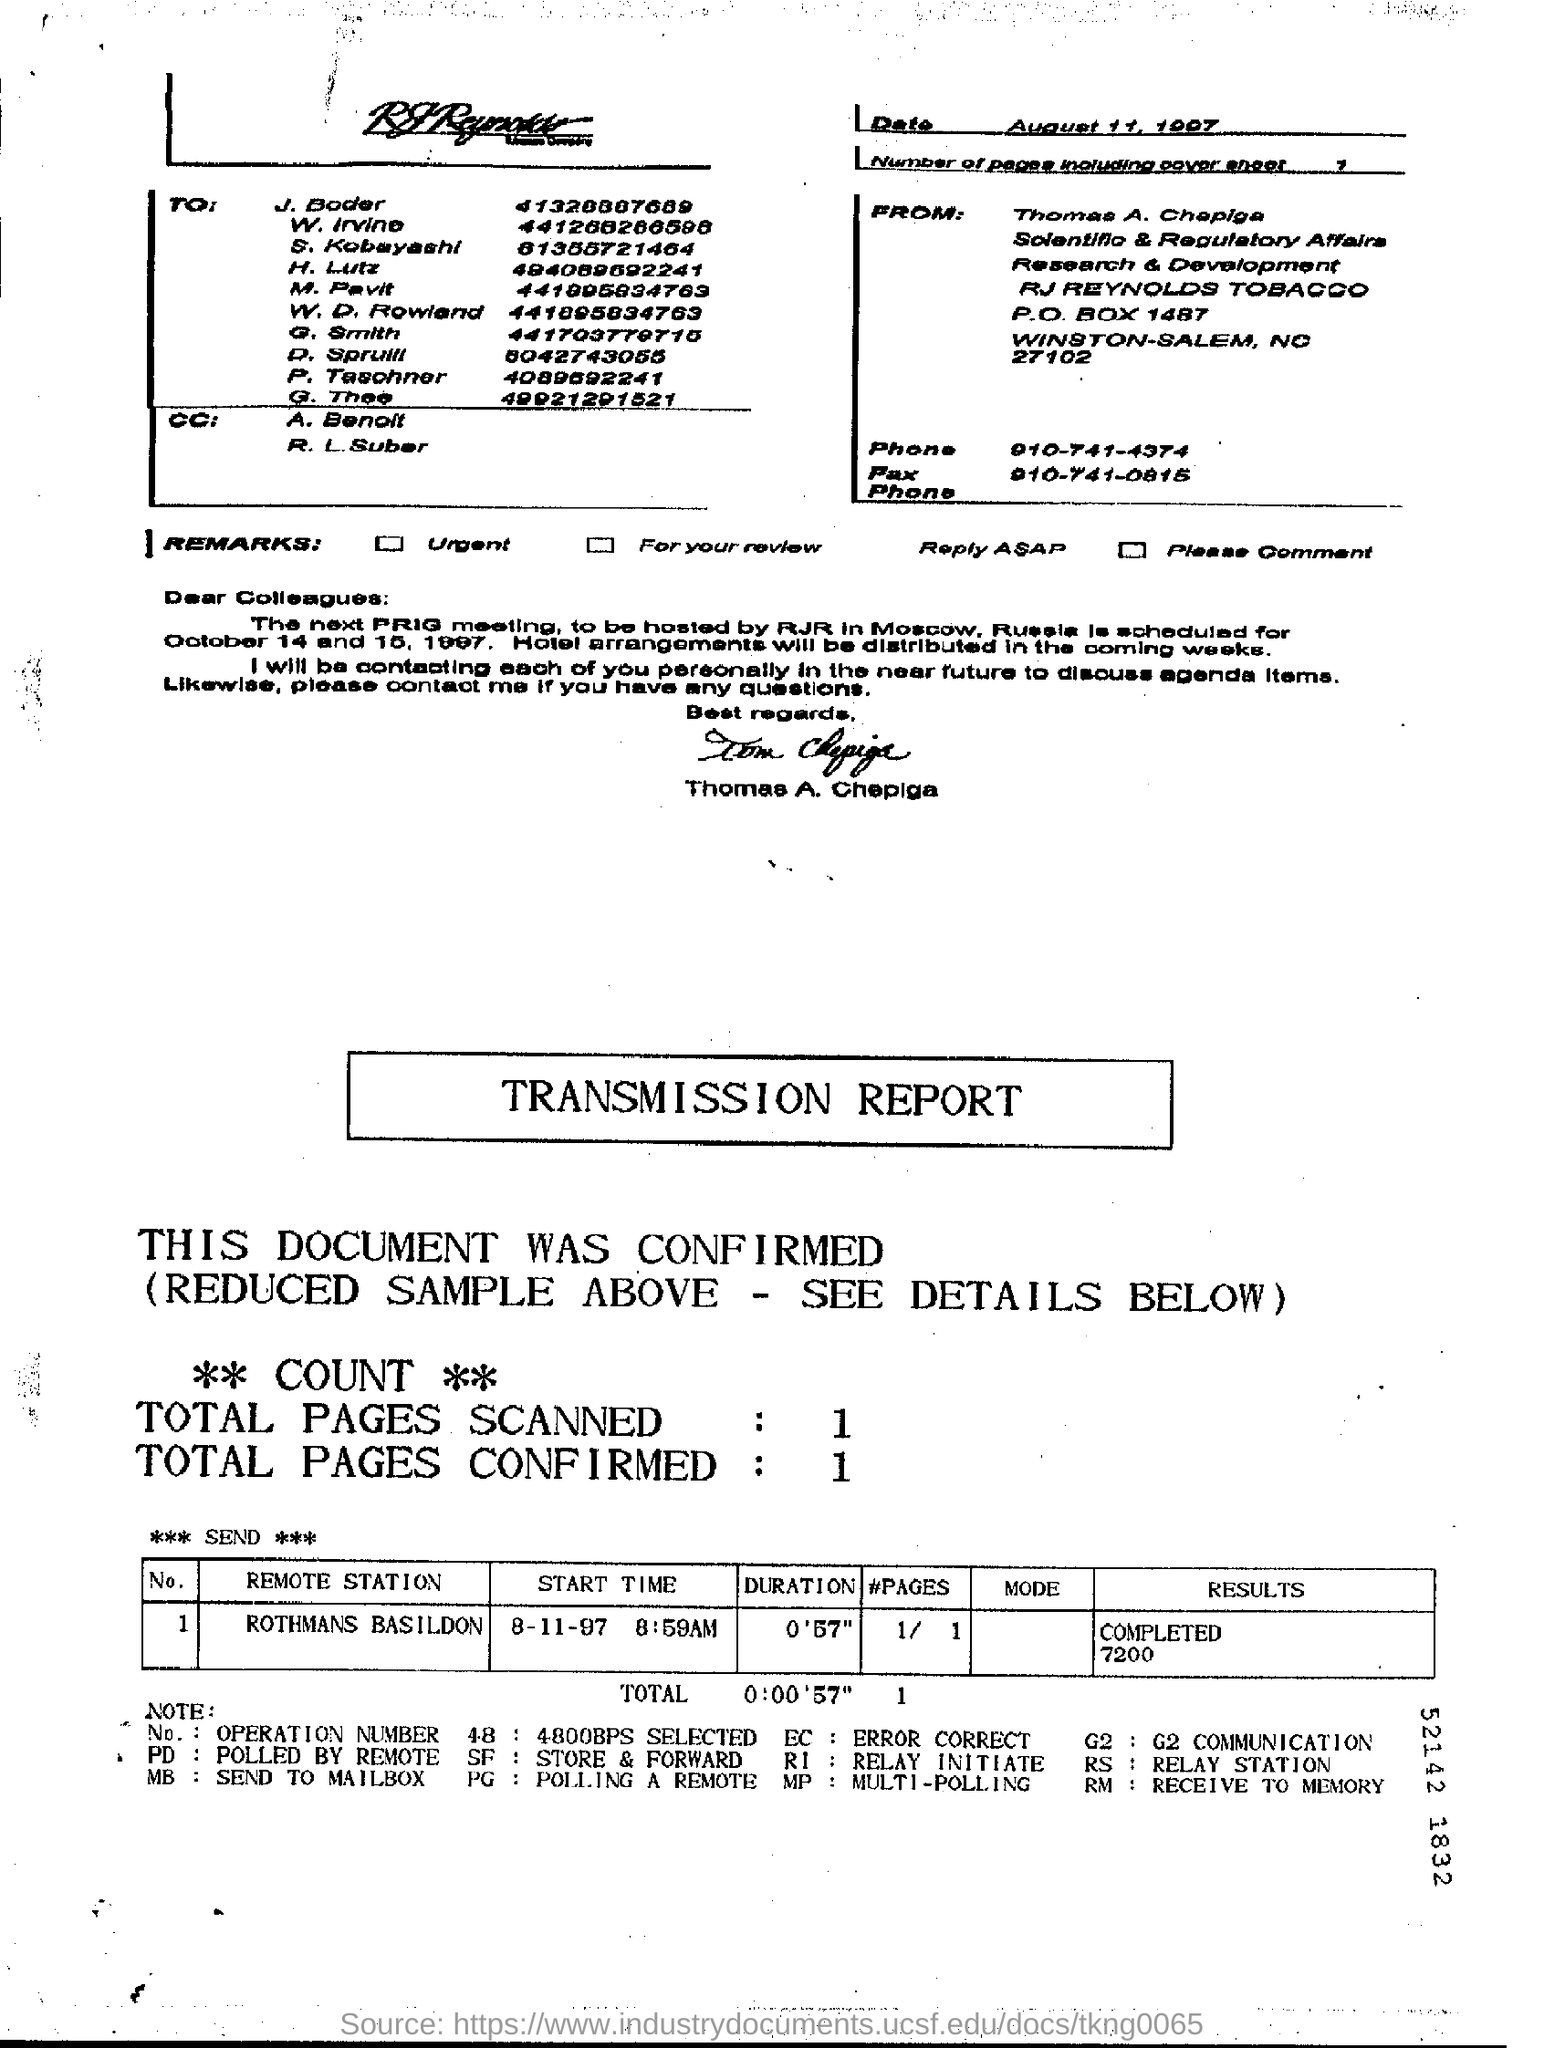Point out several critical features in this image. The next meeting of the PRG is scheduled for October 14 and 15. 